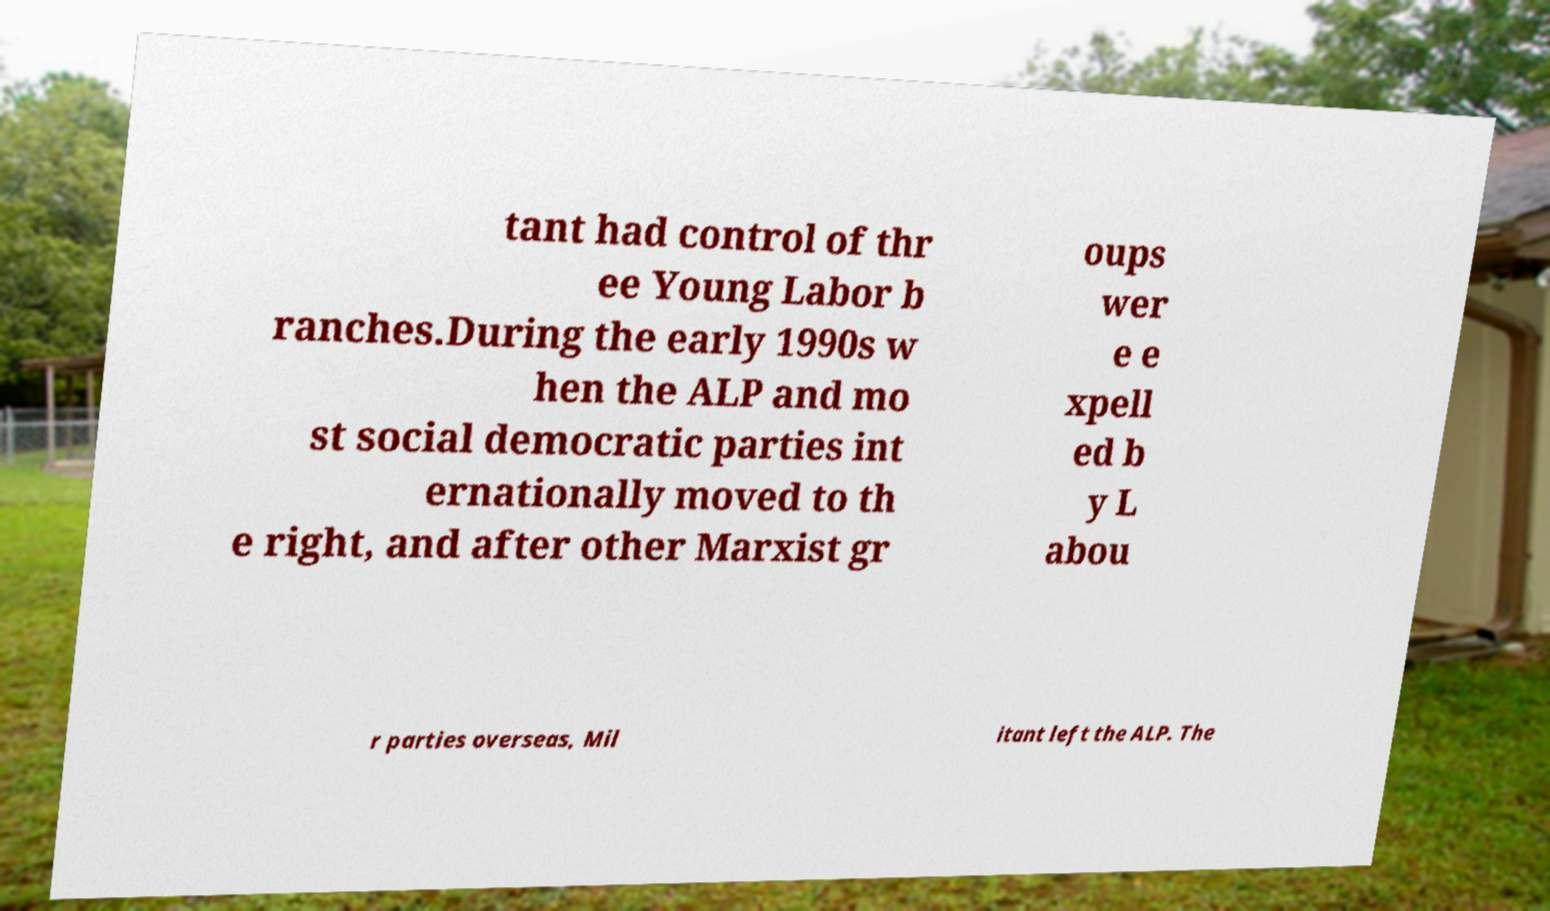I need the written content from this picture converted into text. Can you do that? tant had control of thr ee Young Labor b ranches.During the early 1990s w hen the ALP and mo st social democratic parties int ernationally moved to th e right, and after other Marxist gr oups wer e e xpell ed b y L abou r parties overseas, Mil itant left the ALP. The 